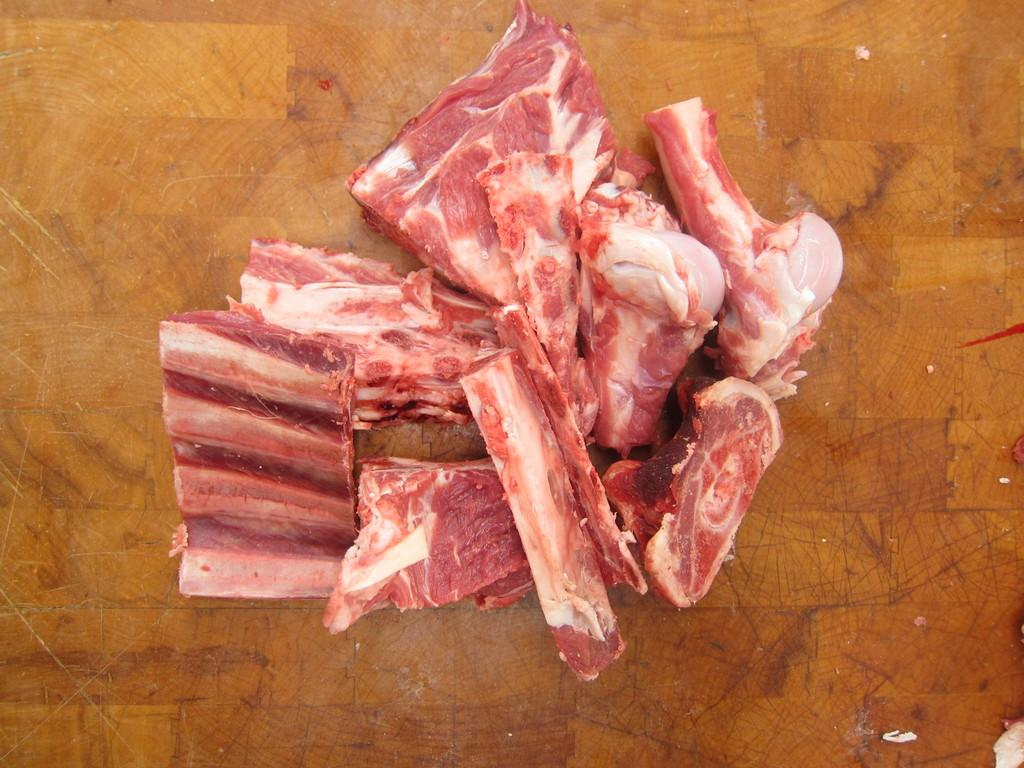What type of surface is visible in the image? There is a wooden surface in the image. What is placed on the wooden surface? There are pieces of raw meat and bones on the wooden surface. What type of shirt is visible on the wooden surface? There is no shirt present on the wooden surface in the image. What shape is the arm on the wooden surface? There is no arm present on the wooden surface in the image. 